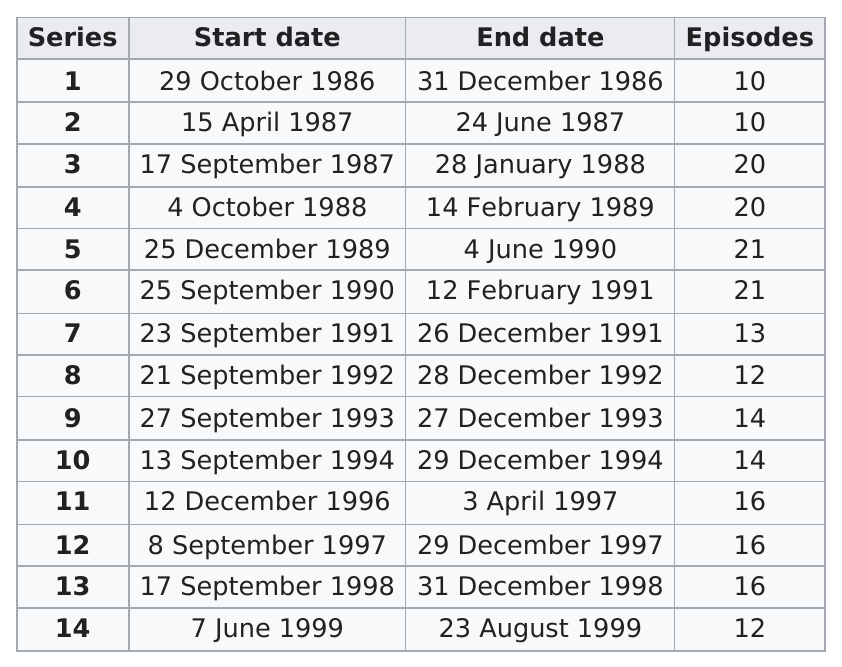Give some essential details in this illustration. There are a total of 40 episodes in series 1-3 combined. 